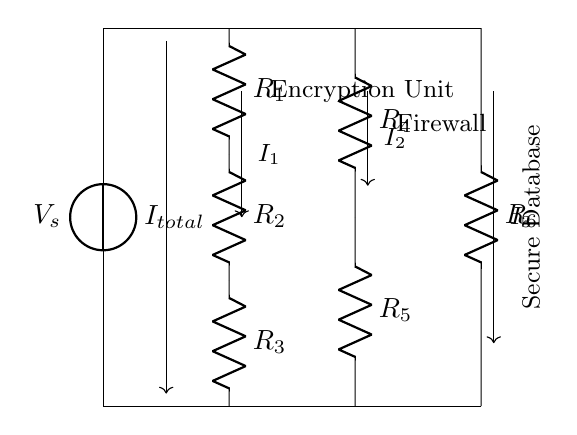What is the source voltage in the circuit? The source voltage, indicated by $V_s$, is present at the top of the circuit and is the potential difference driving the current through the resistors.
Answer: $V_s$ How many resistors are shown in this circuit? Counting the labeled resistors from $R_1$ to $R_6$, there are a total of six distinct resistors in the circuit.
Answer: 6 What type of current flow is depicted in this diagram? The diagram represents a multi-branch current divider, where the total current ($I_{total}$) is split into different branches leading to various components.
Answer: Divider Which component receives the current $I_2$? The current labeled as $I_2$ flows towards the firewall component in the circuit, which is specified in the diagram.
Answer: Firewall What is the relationship between the branch currents ($I_1$, $I_2$, $I_3$) and the total current ($I_{total}$)? The branch currents ($I_1$, $I_2$, and $I_3$) are fractions of the total current ($I_{total}$) based on the resistance values of each resistor connected in parallel within the current divider.
Answer: Division If resistors $R_1$, $R_2$, and $R_3$ are equal in resistance, how are the branch currents related? If $R_1$, $R_2$, and $R_3$ are equal, then $I_1$, $I_2$, and $I_3$ will be equal as well due to symmetry, as the current will evenly divide among the branches with equal resistance.
Answer: Equal 